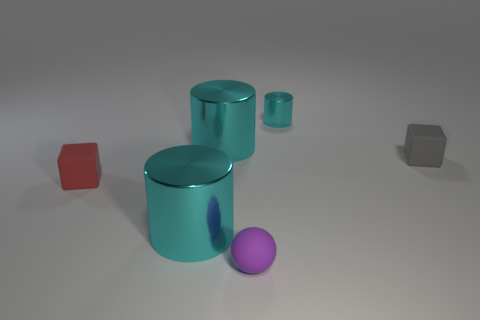Are there any other things of the same color as the small matte ball?
Make the answer very short. No. What number of objects are either big cyan shiny things or tiny things?
Your answer should be compact. 6. There is a cyan metallic object that is the same size as the ball; what shape is it?
Provide a succinct answer. Cylinder. How many tiny matte things are behind the red block and on the left side of the small gray rubber cube?
Provide a short and direct response. 0. What material is the tiny purple sphere to the left of the gray rubber block?
Provide a succinct answer. Rubber. There is a shiny object to the right of the purple thing; does it have the same size as the cyan object that is in front of the tiny red thing?
Ensure brevity in your answer.  No. There is a red thing that is the same size as the purple object; what is it made of?
Give a very brief answer. Rubber. There is a tiny thing that is both behind the purple ball and in front of the tiny gray matte object; what is its material?
Give a very brief answer. Rubber. Are there any small gray blocks?
Provide a succinct answer. Yes. Does the tiny matte ball have the same color as the tiny block left of the gray object?
Offer a terse response. No. 